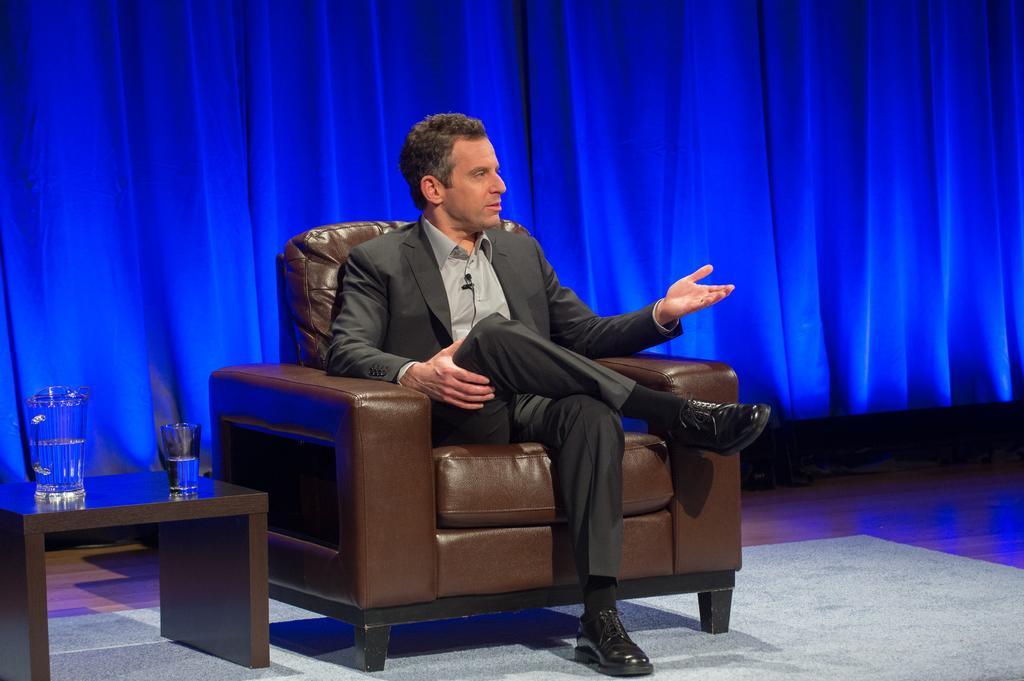Describe this image in one or two sentences. This man wore suit and sitting on a brown couch. On this wooden table there is a jar with water and glass of water. Background there is a blue curtain. A floor with carpet. 